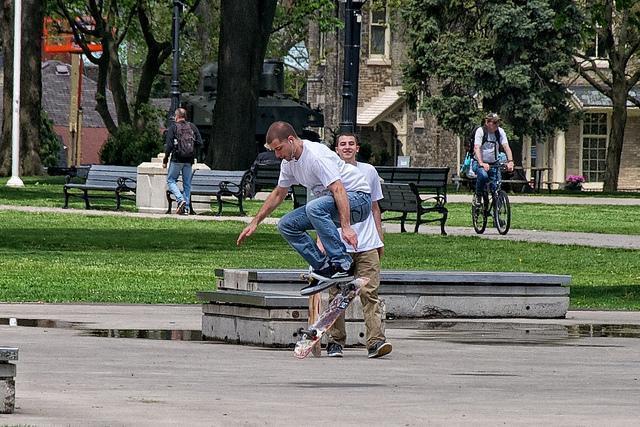How many wheels are there?
Give a very brief answer. 6. How many benches are there?
Give a very brief answer. 5. How many people are in the photo?
Give a very brief answer. 3. How many benches are in the photo?
Give a very brief answer. 2. How many frisbees are laying on the ground?
Give a very brief answer. 0. 